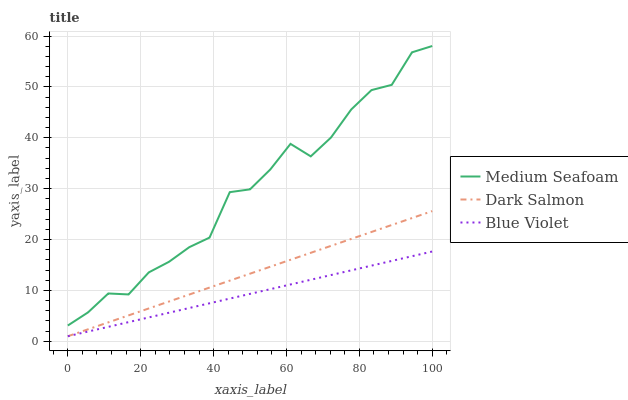Does Blue Violet have the minimum area under the curve?
Answer yes or no. Yes. Does Medium Seafoam have the maximum area under the curve?
Answer yes or no. Yes. Does Dark Salmon have the minimum area under the curve?
Answer yes or no. No. Does Dark Salmon have the maximum area under the curve?
Answer yes or no. No. Is Blue Violet the smoothest?
Answer yes or no. Yes. Is Medium Seafoam the roughest?
Answer yes or no. Yes. Is Dark Salmon the smoothest?
Answer yes or no. No. Is Dark Salmon the roughest?
Answer yes or no. No. Does Blue Violet have the lowest value?
Answer yes or no. Yes. Does Medium Seafoam have the highest value?
Answer yes or no. Yes. Does Dark Salmon have the highest value?
Answer yes or no. No. Is Blue Violet less than Medium Seafoam?
Answer yes or no. Yes. Is Medium Seafoam greater than Blue Violet?
Answer yes or no. Yes. Does Dark Salmon intersect Blue Violet?
Answer yes or no. Yes. Is Dark Salmon less than Blue Violet?
Answer yes or no. No. Is Dark Salmon greater than Blue Violet?
Answer yes or no. No. Does Blue Violet intersect Medium Seafoam?
Answer yes or no. No. 